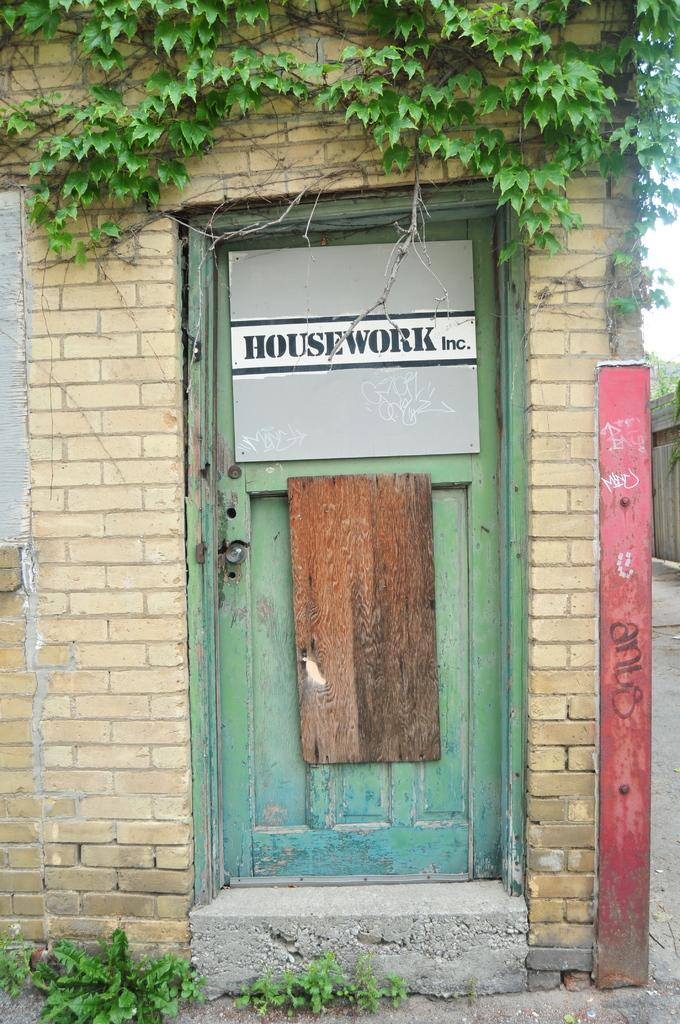What is located in the middle of the house in the image? There is a door in the middle of the house. What can be seen above the door in the image? There are plants above the door. How many cents are visible on the door in the image? There are no cents visible on the door in the image. What type of loss is depicted in the image? There is no loss depicted in the image; it features a door with plants above it. 